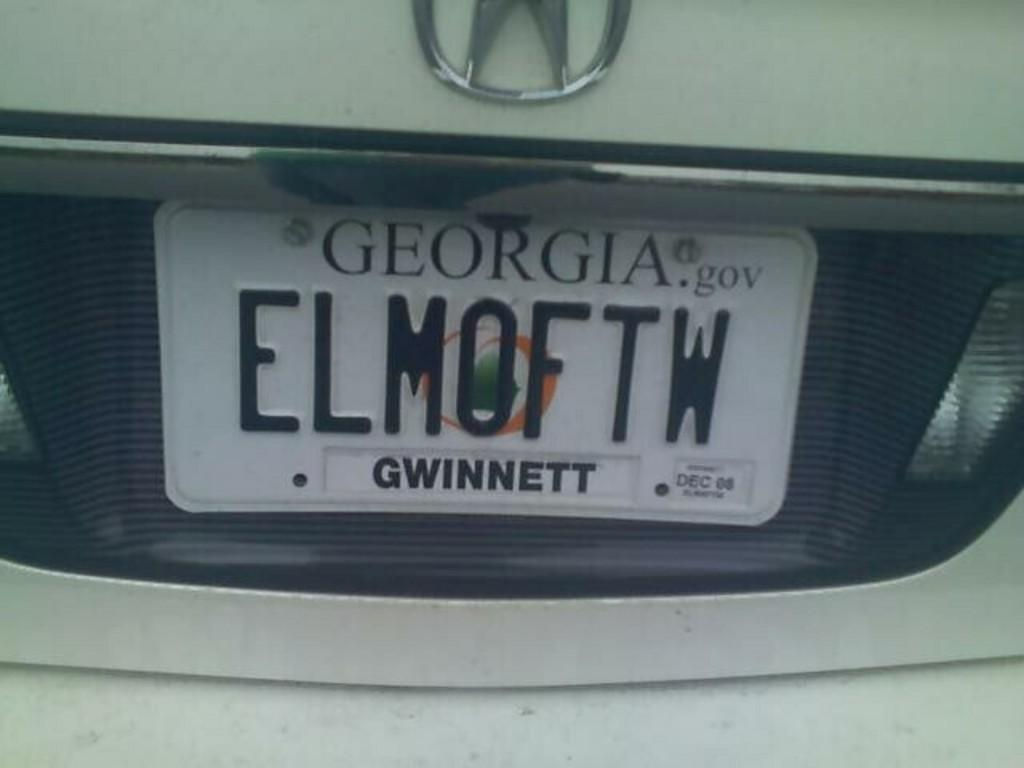<image>
Share a concise interpretation of the image provided. the state of Georgia on the back of a plate 